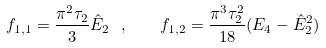Convert formula to latex. <formula><loc_0><loc_0><loc_500><loc_500>f _ { 1 , 1 } = \frac { \pi ^ { 2 } \tau _ { 2 } } { 3 } \hat { E } _ { 2 } \ , \quad f _ { 1 , 2 } = \frac { \pi ^ { 3 } \tau _ { 2 } ^ { 2 } } { 1 8 } ( E _ { 4 } - \hat { E } _ { 2 } ^ { 2 } )</formula> 